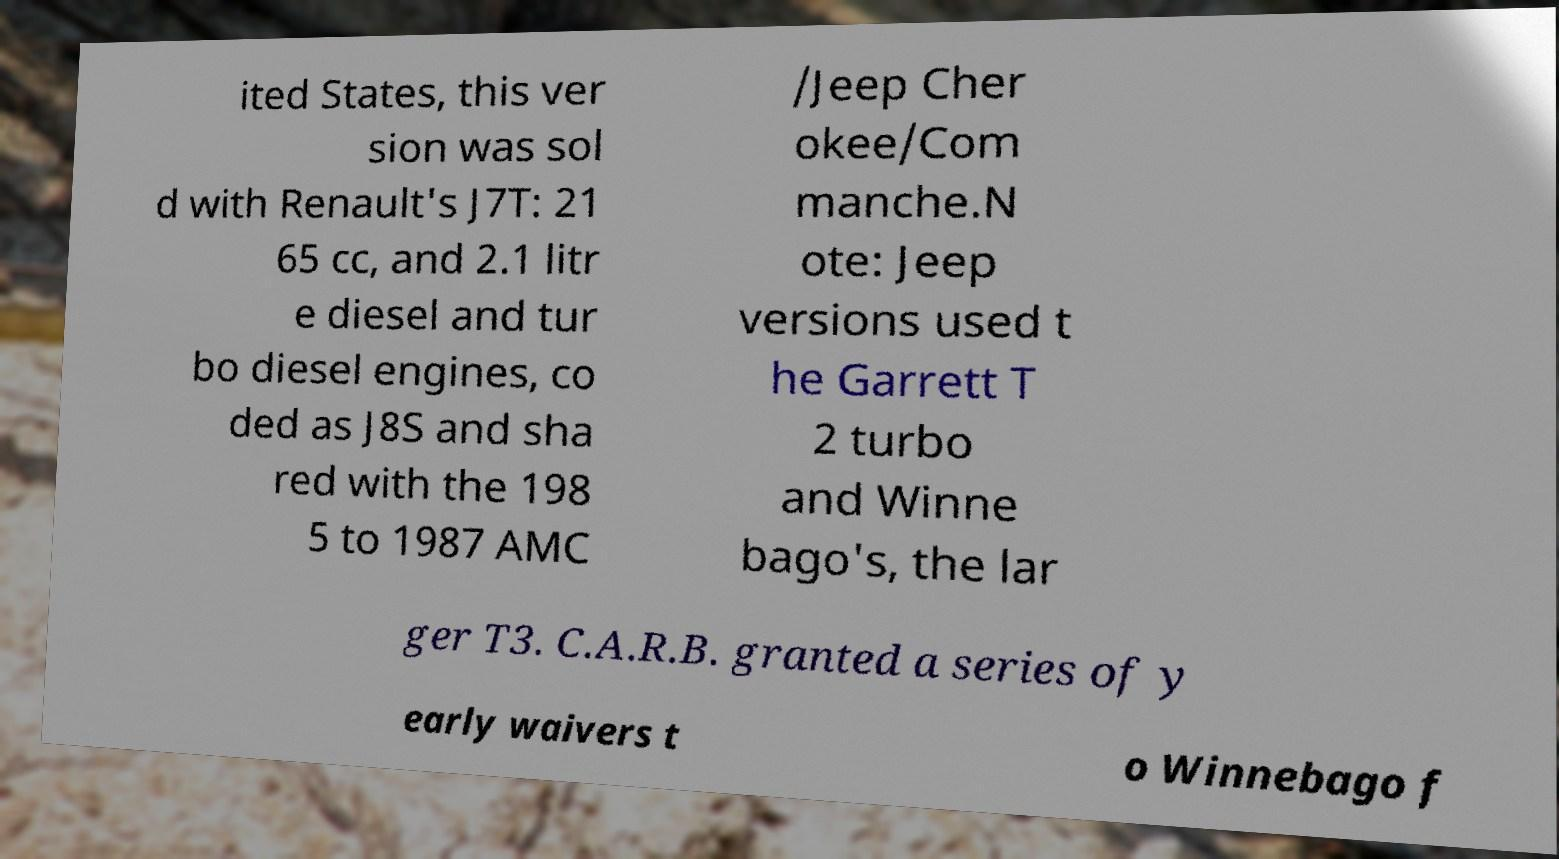I need the written content from this picture converted into text. Can you do that? ited States, this ver sion was sol d with Renault's J7T: 21 65 cc, and 2.1 litr e diesel and tur bo diesel engines, co ded as J8S and sha red with the 198 5 to 1987 AMC /Jeep Cher okee/Com manche.N ote: Jeep versions used t he Garrett T 2 turbo and Winne bago's, the lar ger T3. C.A.R.B. granted a series of y early waivers t o Winnebago f 